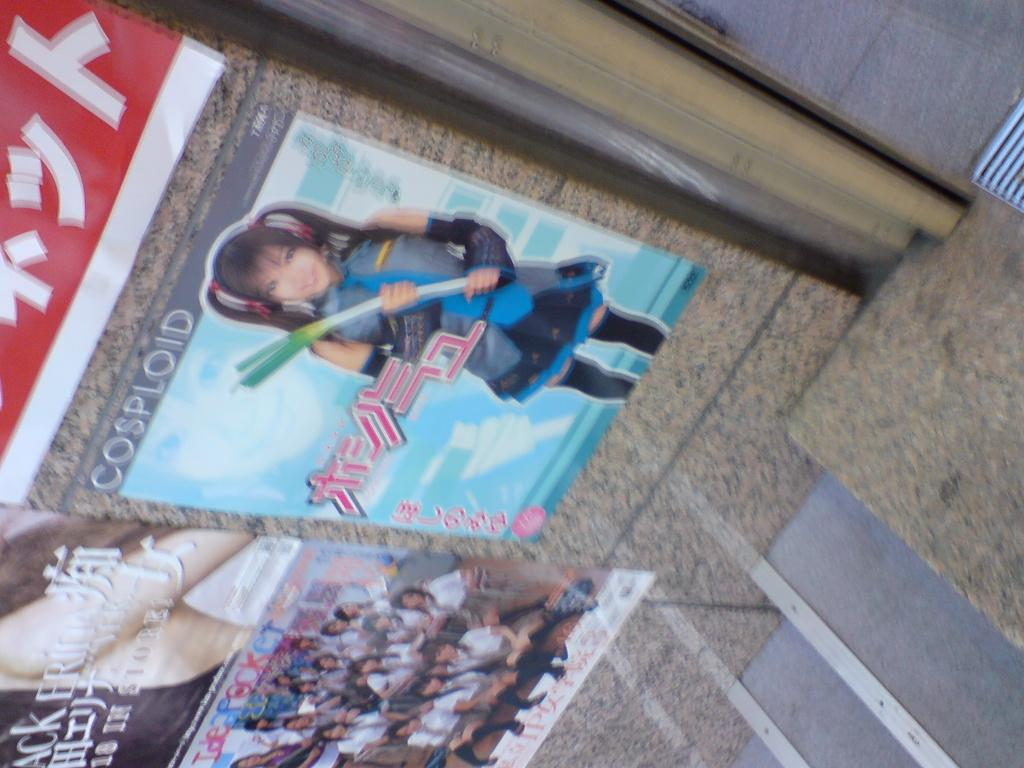What can be seen on the wall in the image? There are posts on the wall in the image. What architectural feature is on the right side of the image? There are stairs on the right side of the image. What surface is visible in the image? There is a floor visible in the image. What type of decorations are on the wall in the image? There are posters with people and text on them in the image. Where is the lunchroom located in the image? There is no lunchroom present in the image; it features posts, stairs, a floor, and posters. 